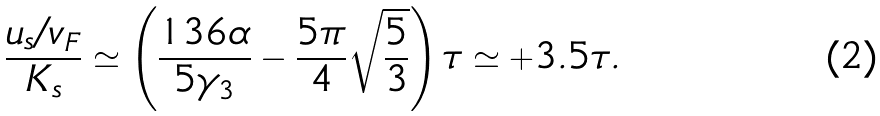<formula> <loc_0><loc_0><loc_500><loc_500>\frac { u _ { s } / v _ { F } } { K _ { s } } \simeq \left ( \frac { 1 3 6 \alpha } { 5 \gamma _ { 3 } } - \frac { 5 \pi } 4 \sqrt { \frac { 5 } { 3 } } \right ) \tau \simeq + 3 . 5 \tau .</formula> 